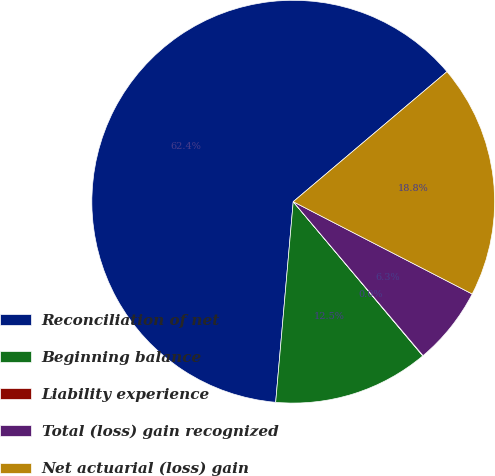<chart> <loc_0><loc_0><loc_500><loc_500><pie_chart><fcel>Reconciliation of net<fcel>Beginning balance<fcel>Liability experience<fcel>Total (loss) gain recognized<fcel>Net actuarial (loss) gain<nl><fcel>62.43%<fcel>12.51%<fcel>0.03%<fcel>6.27%<fcel>18.75%<nl></chart> 